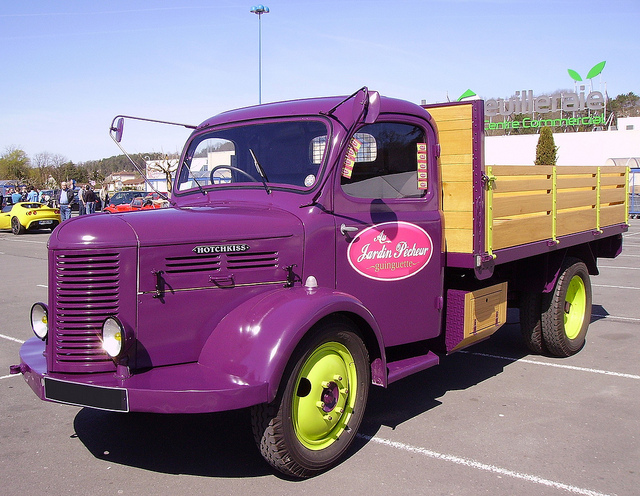<image>What company owns this truck? I am not sure which company owns this truck. It could be 'jordan picker', 'jordin picker', 'jordan proctor', 'jordin probar', 'jordan parker', 'jordan peckers', 'jordan pechar', or 'jordon pecker'. What company owns this truck? I don't know which company owns this truck. It can be 'jordan picker', 'jordin picker', 'jordan proctor' or 'jordin probar'. 